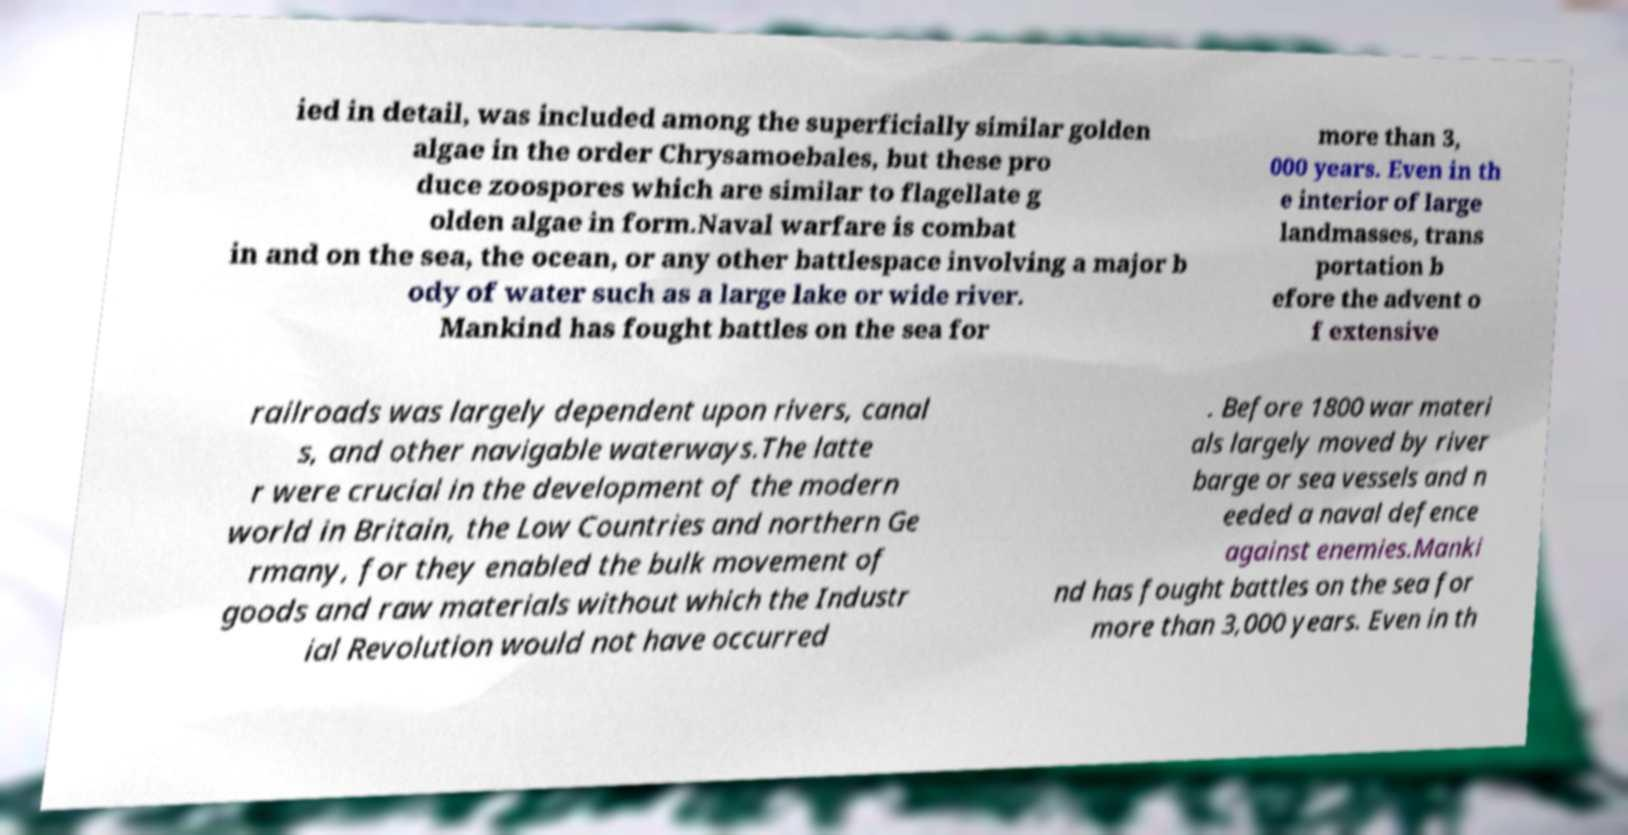There's text embedded in this image that I need extracted. Can you transcribe it verbatim? ied in detail, was included among the superficially similar golden algae in the order Chrysamoebales, but these pro duce zoospores which are similar to flagellate g olden algae in form.Naval warfare is combat in and on the sea, the ocean, or any other battlespace involving a major b ody of water such as a large lake or wide river. Mankind has fought battles on the sea for more than 3, 000 years. Even in th e interior of large landmasses, trans portation b efore the advent o f extensive railroads was largely dependent upon rivers, canal s, and other navigable waterways.The latte r were crucial in the development of the modern world in Britain, the Low Countries and northern Ge rmany, for they enabled the bulk movement of goods and raw materials without which the Industr ial Revolution would not have occurred . Before 1800 war materi als largely moved by river barge or sea vessels and n eeded a naval defence against enemies.Manki nd has fought battles on the sea for more than 3,000 years. Even in th 